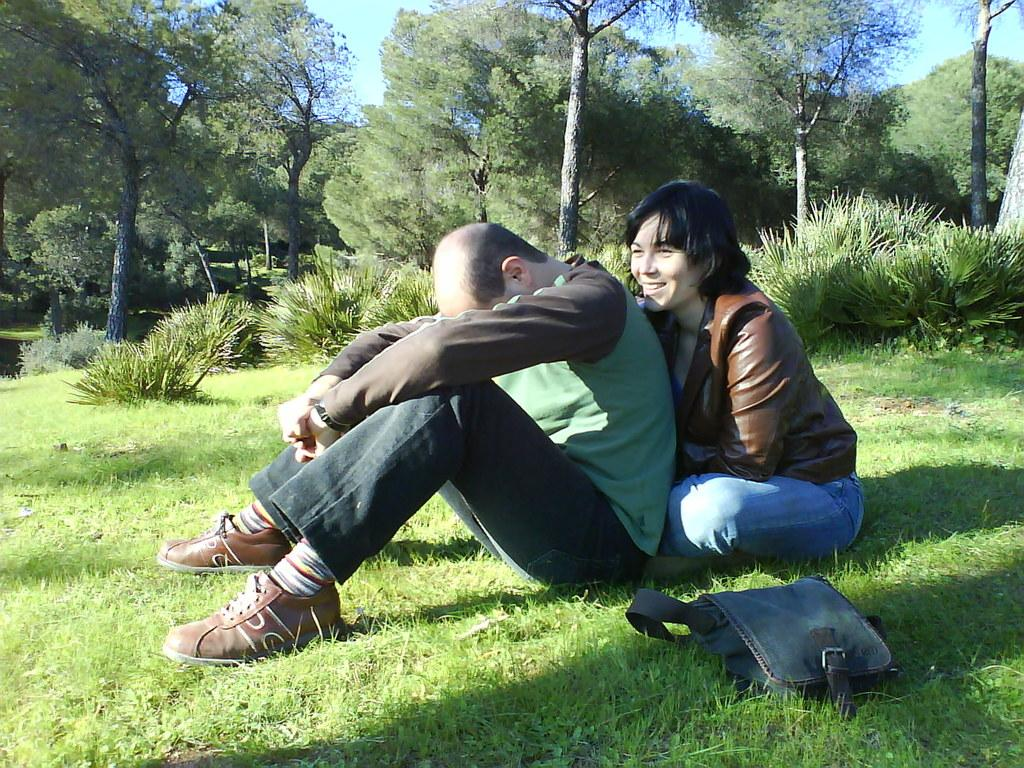Where was the image taken? The image was taken outside. What type of ground is visible at the bottom of the image? There is grass at the bottom of the image. What can be seen at the top of the image? There are trees at the top of the image. How many people are sitting in the middle of the image? There are two persons sitting in the middle of the image. What object is present at the bottom of the image? There is a bag at the bottom of the image. What type of produce is being dropped by the tree in the image? There is no produce being dropped by a tree in the image; there are only trees visible at the top of the image. 